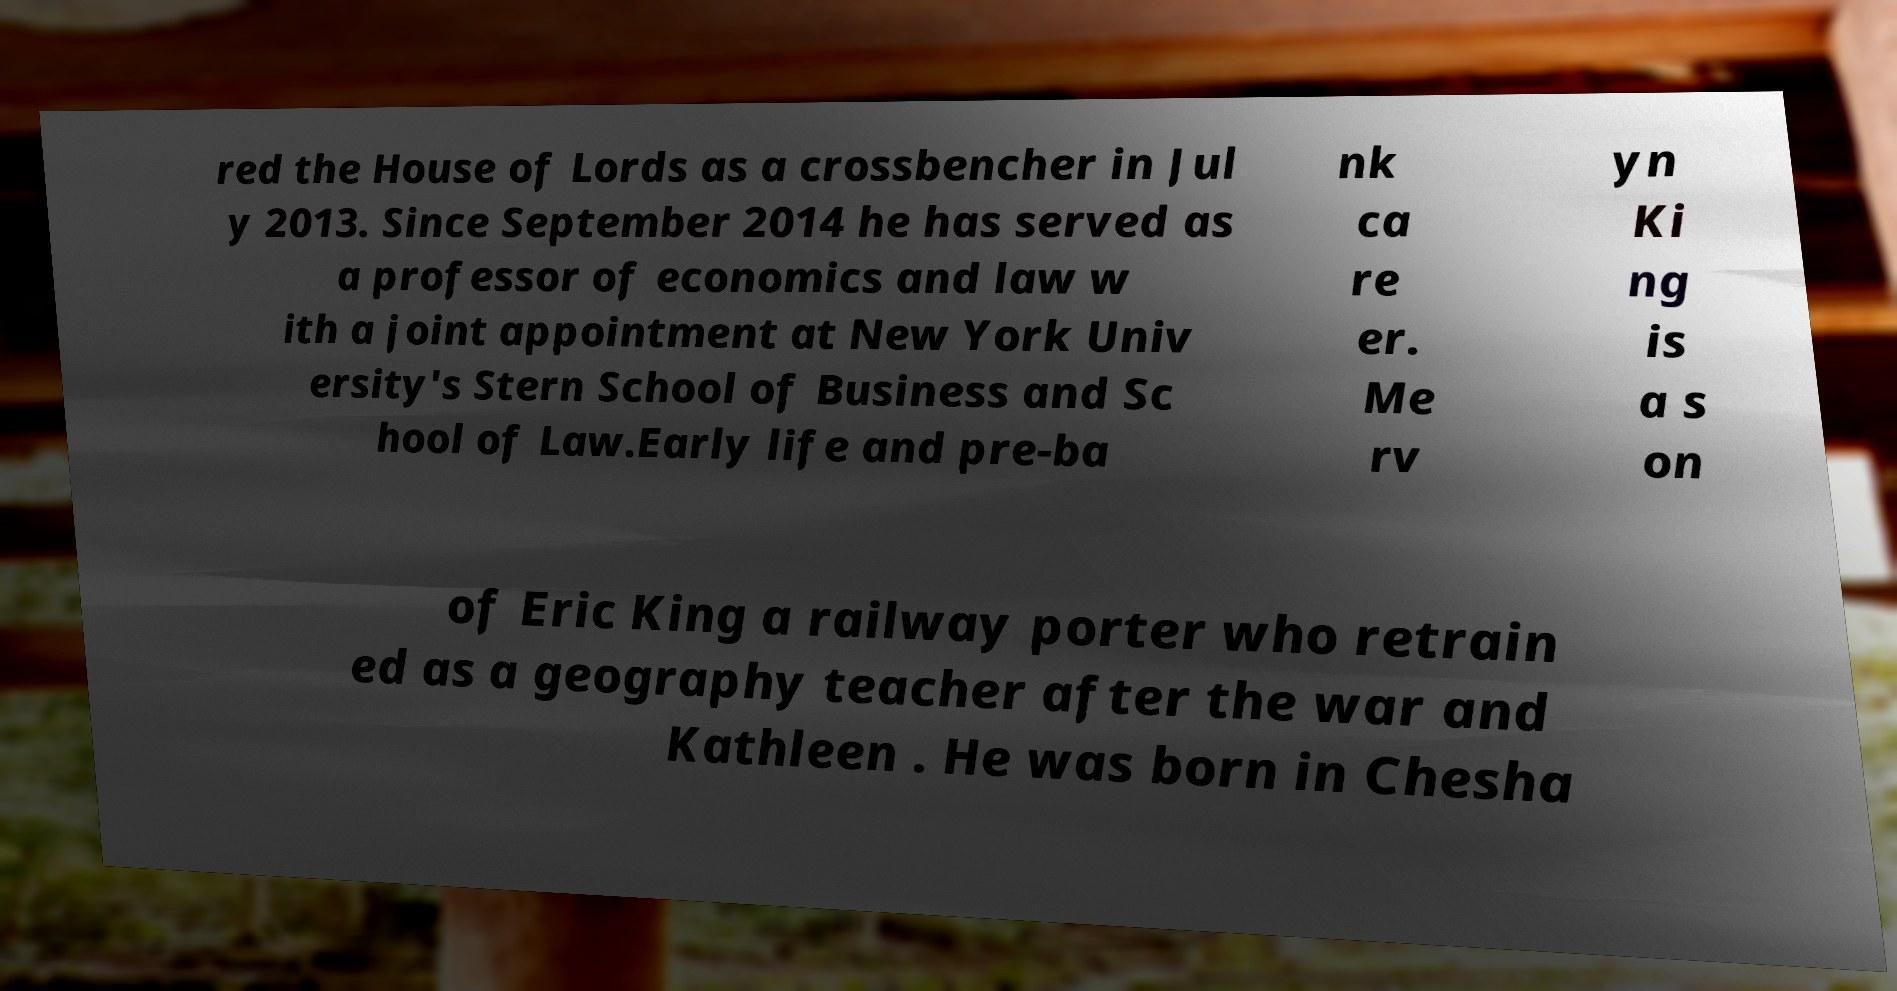There's text embedded in this image that I need extracted. Can you transcribe it verbatim? red the House of Lords as a crossbencher in Jul y 2013. Since September 2014 he has served as a professor of economics and law w ith a joint appointment at New York Univ ersity's Stern School of Business and Sc hool of Law.Early life and pre-ba nk ca re er. Me rv yn Ki ng is a s on of Eric King a railway porter who retrain ed as a geography teacher after the war and Kathleen . He was born in Chesha 